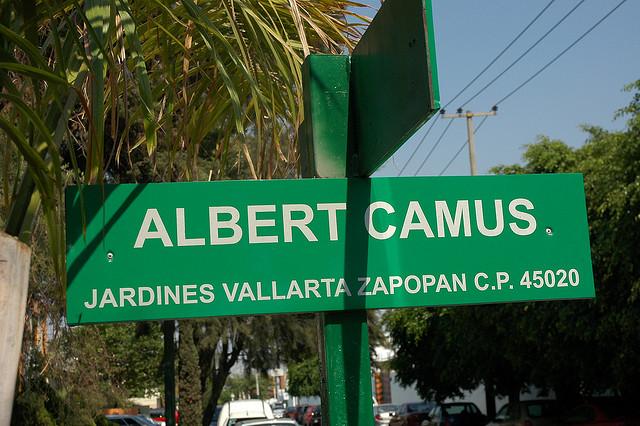What type of tree is in the background?
Answer briefly. Palm. What does the green sign say?
Quick response, please. Albert camus. What does this sign say?
Short answer required. Albert camus. Does this sign appear to be in the United States?
Be succinct. No. Is this a street sign?
Be succinct. Yes. 